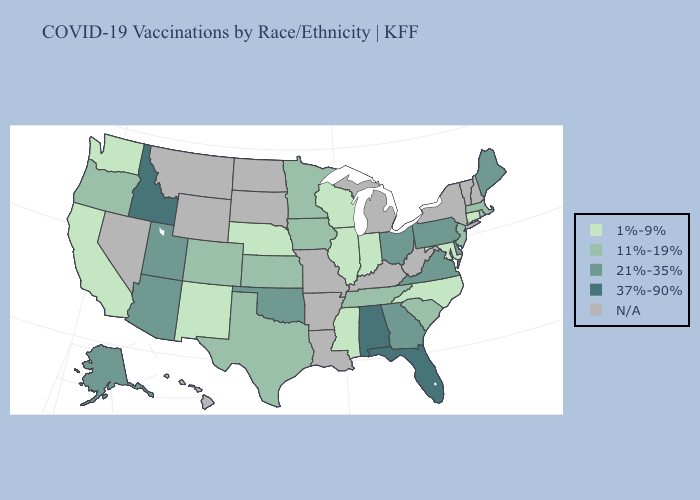Name the states that have a value in the range 1%-9%?
Concise answer only. California, Connecticut, Illinois, Indiana, Maryland, Mississippi, Nebraska, New Mexico, North Carolina, Washington, Wisconsin. What is the lowest value in the South?
Keep it brief. 1%-9%. What is the highest value in states that border Oklahoma?
Keep it brief. 11%-19%. Does the first symbol in the legend represent the smallest category?
Concise answer only. Yes. How many symbols are there in the legend?
Give a very brief answer. 5. Does the first symbol in the legend represent the smallest category?
Concise answer only. Yes. What is the value of Nebraska?
Be succinct. 1%-9%. Name the states that have a value in the range 21%-35%?
Keep it brief. Alaska, Arizona, Delaware, Georgia, Maine, Ohio, Oklahoma, Pennsylvania, Utah, Virginia. Name the states that have a value in the range 21%-35%?
Write a very short answer. Alaska, Arizona, Delaware, Georgia, Maine, Ohio, Oklahoma, Pennsylvania, Utah, Virginia. Does Ohio have the highest value in the MidWest?
Answer briefly. Yes. Among the states that border Arkansas , does Oklahoma have the highest value?
Concise answer only. Yes. What is the value of Nevada?
Keep it brief. N/A. 